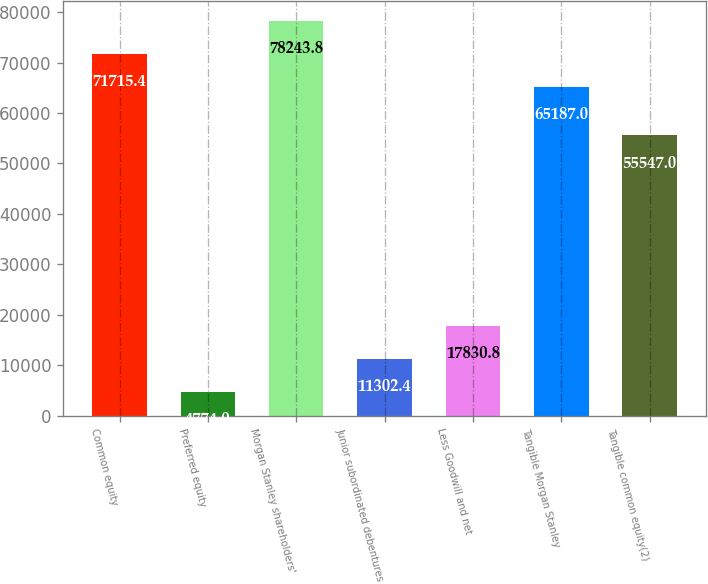Convert chart to OTSL. <chart><loc_0><loc_0><loc_500><loc_500><bar_chart><fcel>Common equity<fcel>Preferred equity<fcel>Morgan Stanley shareholders'<fcel>Junior subordinated debentures<fcel>Less Goodwill and net<fcel>Tangible Morgan Stanley<fcel>Tangible common equity(2)<nl><fcel>71715.4<fcel>4774<fcel>78243.8<fcel>11302.4<fcel>17830.8<fcel>65187<fcel>55547<nl></chart> 